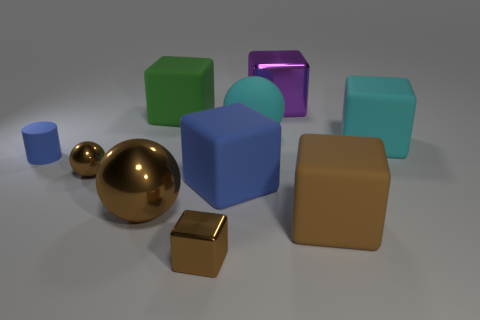Subtract all green rubber cubes. How many cubes are left? 5 Subtract 1 blocks. How many blocks are left? 5 Subtract all green cubes. How many cubes are left? 5 Subtract all brown blocks. Subtract all yellow spheres. How many blocks are left? 4 Subtract all balls. How many objects are left? 7 Subtract 1 cyan spheres. How many objects are left? 9 Subtract all cyan matte things. Subtract all metallic balls. How many objects are left? 6 Add 6 tiny brown metallic blocks. How many tiny brown metallic blocks are left? 7 Add 2 big blue rubber things. How many big blue rubber things exist? 3 